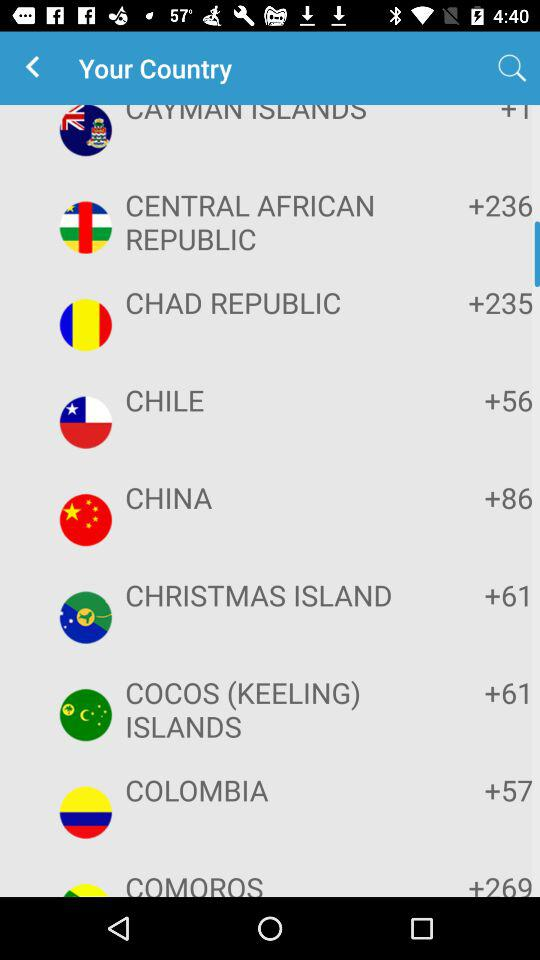What is the code for Chile? The code for Chile is +56. 